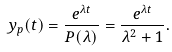Convert formula to latex. <formula><loc_0><loc_0><loc_500><loc_500>y _ { p } ( t ) = { \frac { e ^ { \lambda t } } { P ( \lambda ) } } = { \frac { e ^ { \lambda t } } { \lambda ^ { 2 } + 1 } } .</formula> 